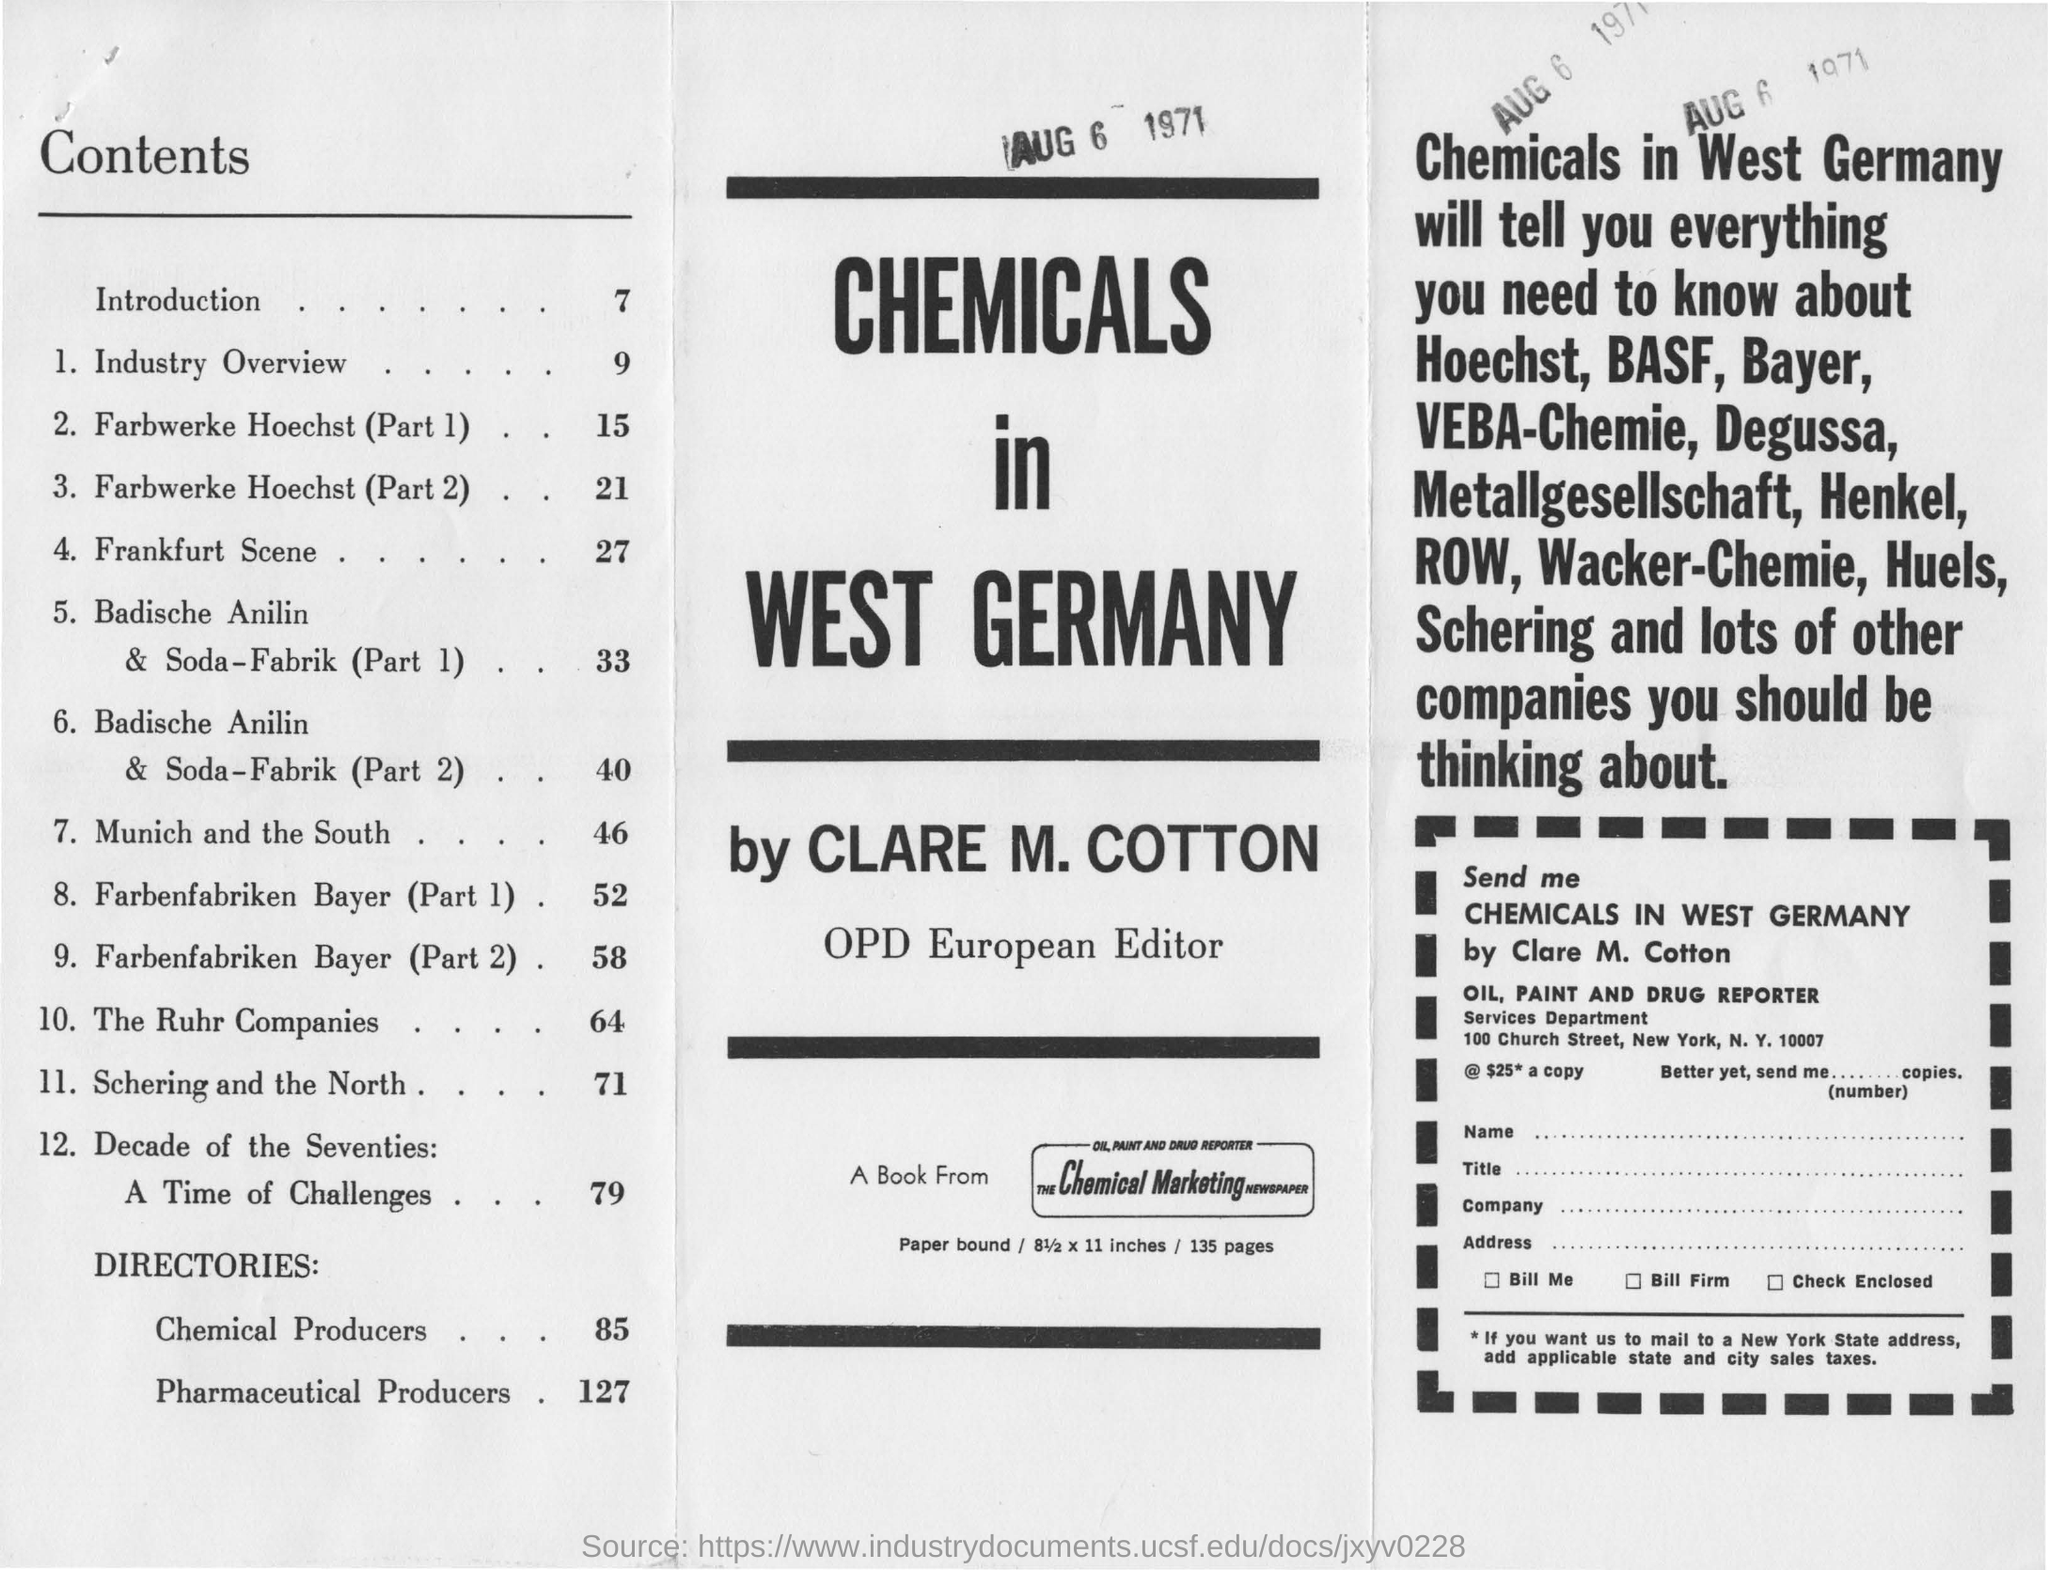What page is the introduction on?
Offer a very short reply. 7. What page is industry overview on?
Provide a succinct answer. 9. What is the name of the book?
Keep it short and to the point. CHEMICALS IN WEST GERMANY. Who wrote chemicals in west germany?
Your answer should be compact. CLARE M. COTTON. Who is the book from?
Give a very brief answer. The chemical marketing newspaper. 